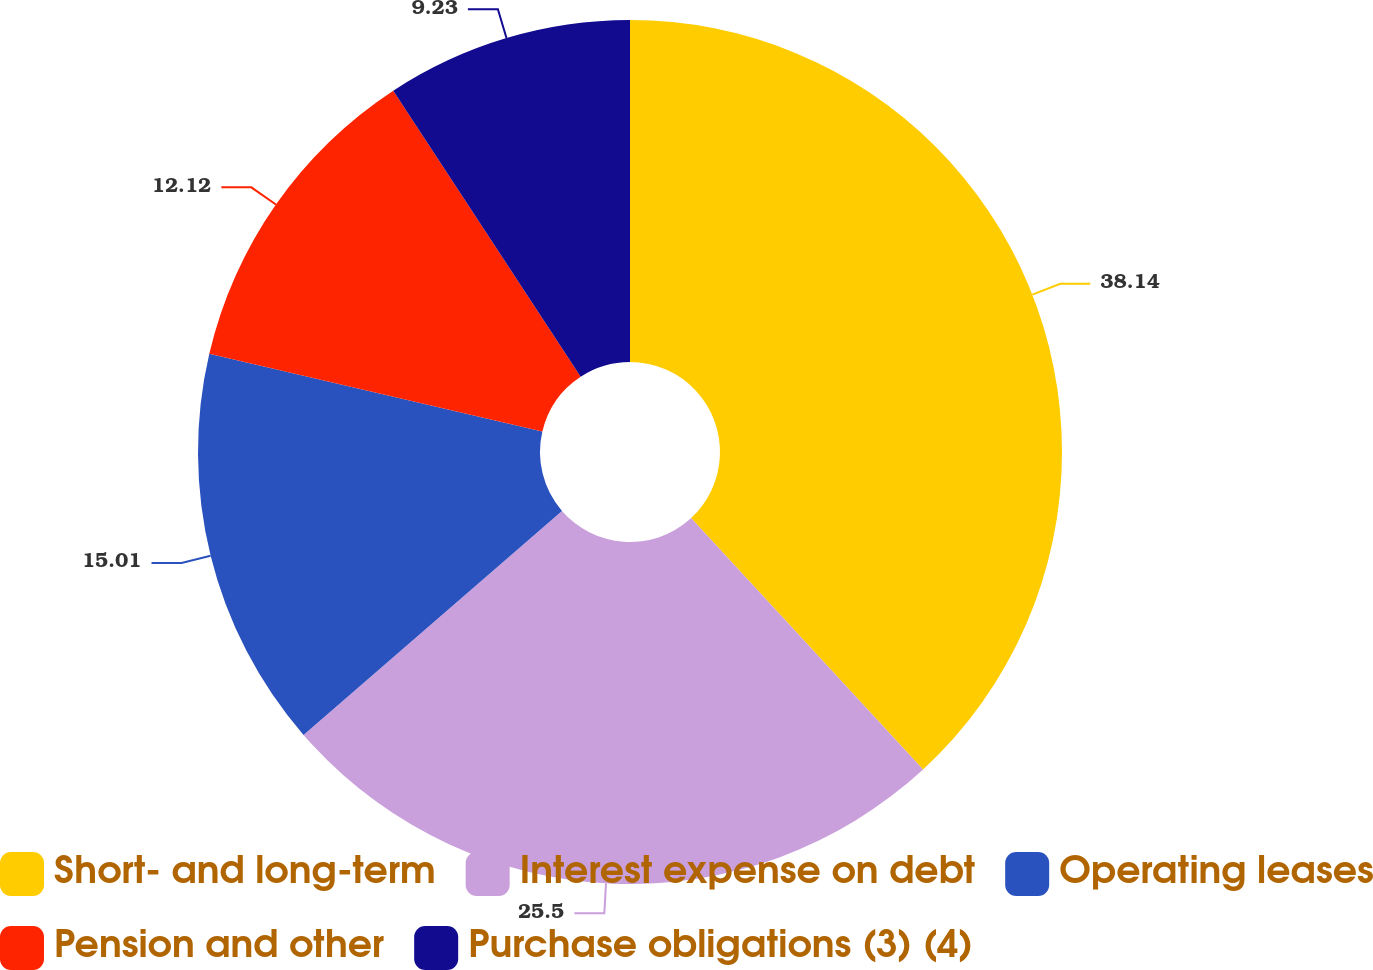Convert chart to OTSL. <chart><loc_0><loc_0><loc_500><loc_500><pie_chart><fcel>Short- and long-term<fcel>Interest expense on debt<fcel>Operating leases<fcel>Pension and other<fcel>Purchase obligations (3) (4)<nl><fcel>38.13%<fcel>25.5%<fcel>15.01%<fcel>12.12%<fcel>9.23%<nl></chart> 